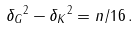<formula> <loc_0><loc_0><loc_500><loc_500>\| \delta _ { G } \| ^ { 2 } - \| \delta _ { K } \| ^ { 2 } = n / 1 6 \, .</formula> 